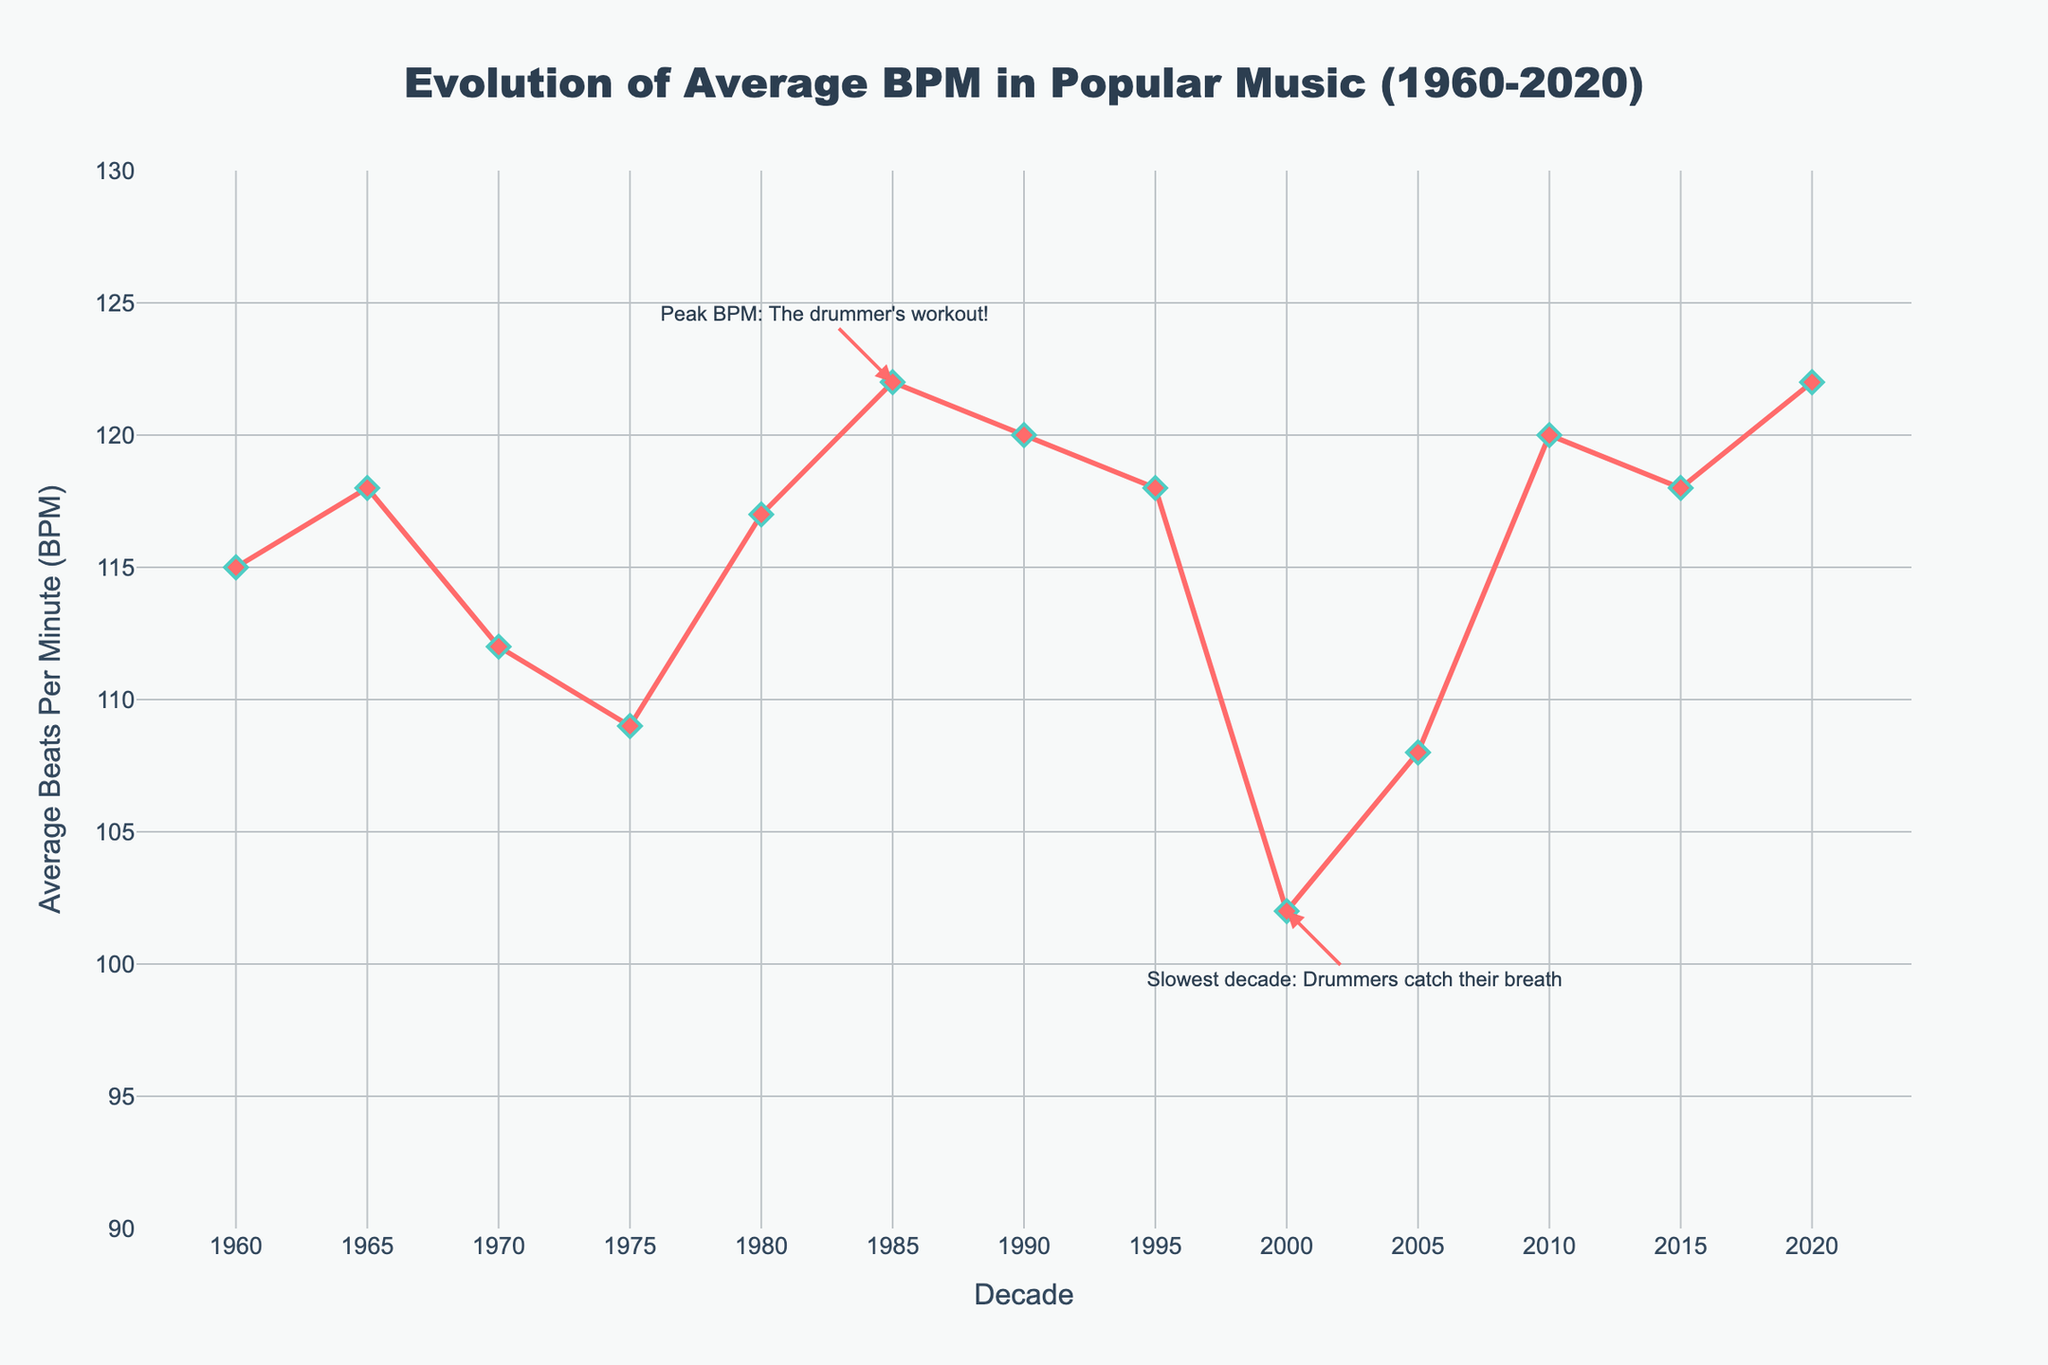What's the average BPM for the decades 1970, 1980, and 1990 combined? Add the average BPM values for 1970 (112), 1980 (117), and 1990 (120) and divide by 3. (112 + 117 + 120) / 3 = 349 / 3 ≈ 116.33
Answer: 116.33 Between which two decades is there the largest decrease in average BPM? Identify the largest drop by comparing BPM values for subsequent decades: 
1965-1970: 118 to 112 (6), 
1970-1975: 112 to 109 (3), 
1985-1990: 122 to 120 (2), 
1995-2000: 118 to 102 (16). 
The largest decrease is between 1995 and 2000.
Answer: 1995 to 2000 During which decade did the average BPM begin to rise again after a period of decline? By examining the trend, from 1975 BPM starts to rise in 1980 after declining.
Answer: 1980 How much did the average BPM increase from 2005 to 2020? Subtract the average BPM in 2005 (108) from 2020 (122). 122 - 108 = 14
Answer: 14 What is the highest peak in the average BPM over these decades? According to the chart, the highest average BPM is marked at 1985 and 2020 (both 122).
Answer: 122 Which decade has the lowest average BPM? From the chart, the lowest average BPM is in the year 2000, which is 102.
Answer: 2000 How does the average BPM in 2015 compare to that in 2005? Compare the values of average BPM in 2015 (118) and 2005 (108). 2015 is higher by 10.
Answer: 10 more What trend in BPM is noticeable from 1995 to 2005? From 1995 (118) to 2000 (102), the BPM significantly drops, then slightly increases in 2005 (108).
Answer: Drop then Rise 